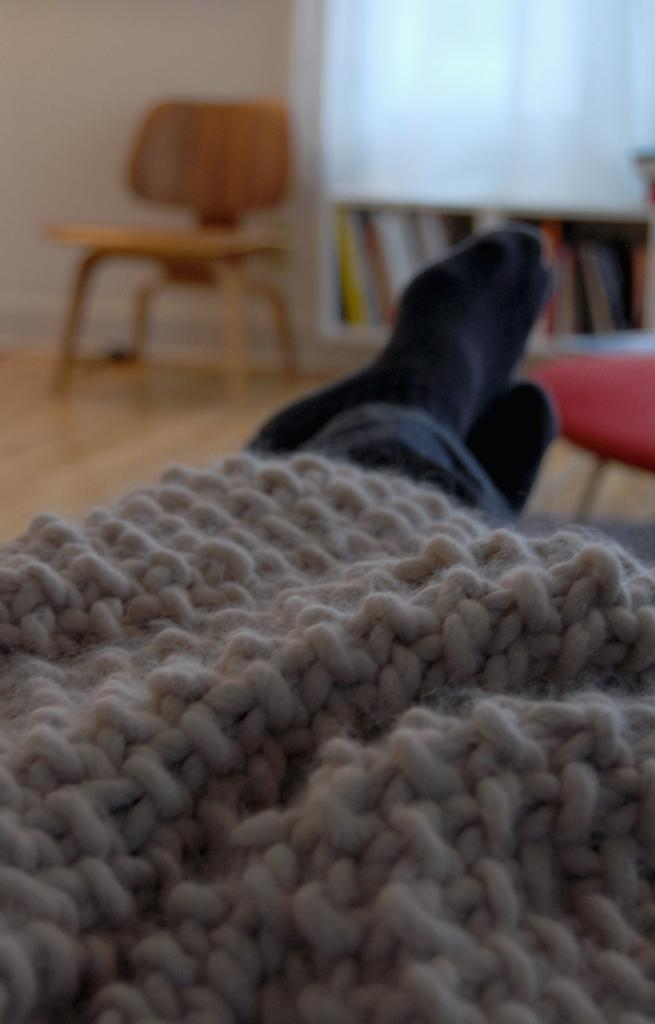What can be seen in the image related to a person's lower body? There are person's legs and cloth in the image. What type of furniture is present in the image? There are chairs in the image. What is the background of the image made of? There is a wall in the image. Where are the books located in the image? The books are on a rack in the image. Can you see a nest in the image? There is no nest present in the image. What type of grain is being used to copy the books in the image? There is no grain or copying activity involving books in the image. 